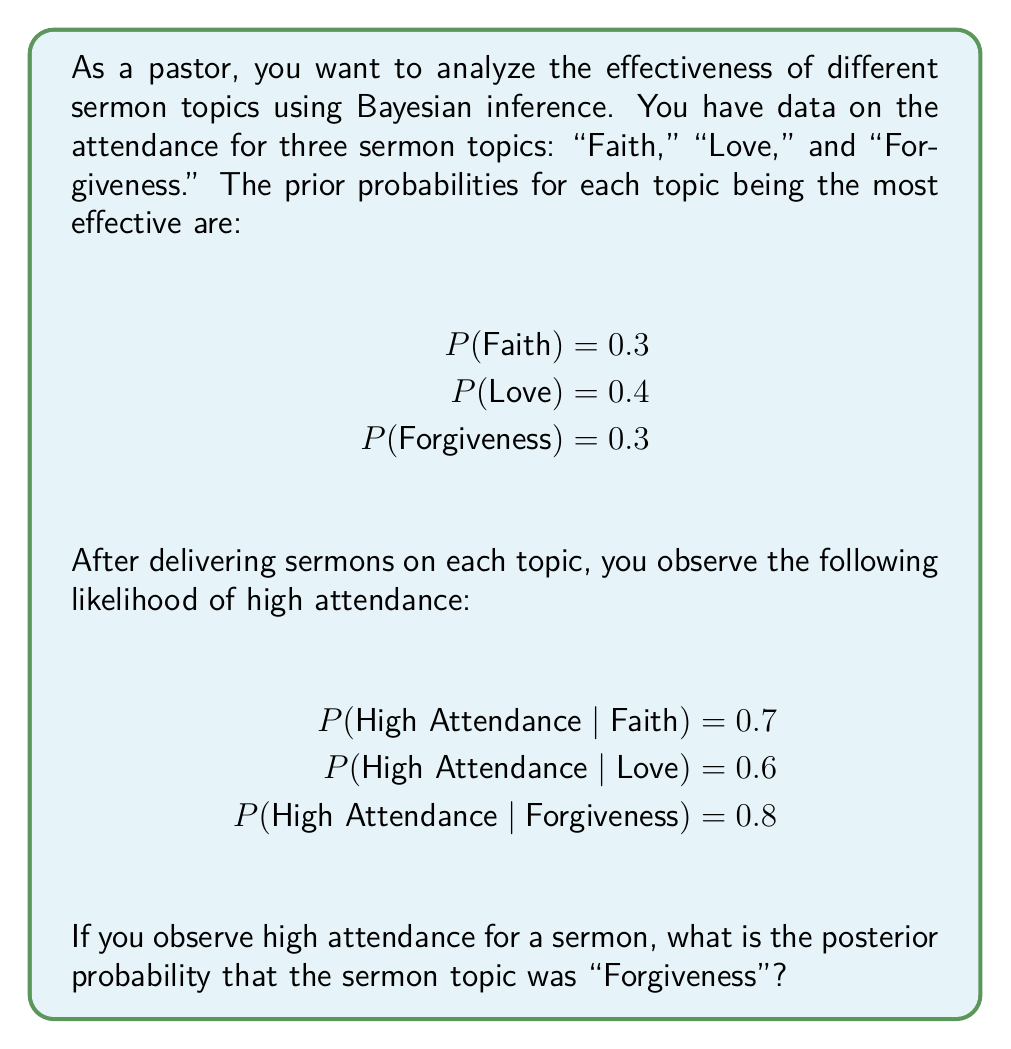Help me with this question. To solve this problem, we'll use Bayes' theorem:

$$P(A|B) = \frac{P(B|A) \cdot P(A)}{P(B)}$$

Where:
A = Forgiveness sermon topic
B = High attendance

Step 1: Identify the given probabilities
- P(Forgiveness) = 0.3 (prior probability)
- P(High Attendance | Forgiveness) = 0.8 (likelihood)

Step 2: Calculate P(B) using the law of total probability
$$P(B) = P(B|Faith) \cdot P(Faith) + P(B|Love) \cdot P(Love) + P(B|Forgiveness) \cdot P(Forgiveness)$$
$$P(B) = 0.7 \cdot 0.3 + 0.6 \cdot 0.4 + 0.8 \cdot 0.3 = 0.21 + 0.24 + 0.24 = 0.69$$

Step 3: Apply Bayes' theorem
$$P(Forgiveness|High Attendance) = \frac{P(High Attendance|Forgiveness) \cdot P(Forgiveness)}{P(High Attendance)}$$

$$P(Forgiveness|High Attendance) = \frac{0.8 \cdot 0.3}{0.69} = \frac{0.24}{0.69} \approx 0.3478$$

Step 4: Convert to a percentage
0.3478 × 100% ≈ 34.78%
Answer: 34.78% 